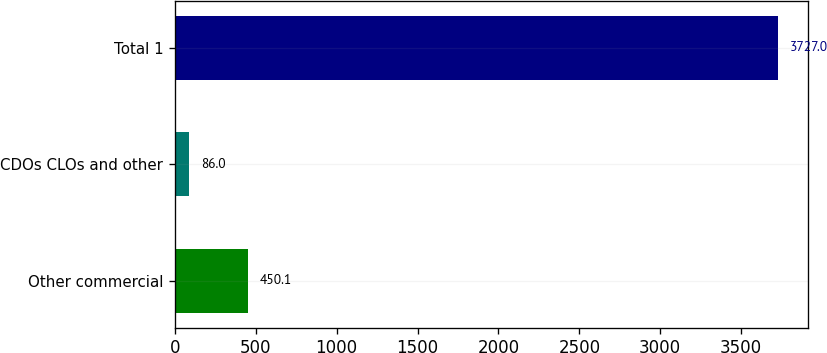<chart> <loc_0><loc_0><loc_500><loc_500><bar_chart><fcel>Other commercial<fcel>CDOs CLOs and other<fcel>Total 1<nl><fcel>450.1<fcel>86<fcel>3727<nl></chart> 